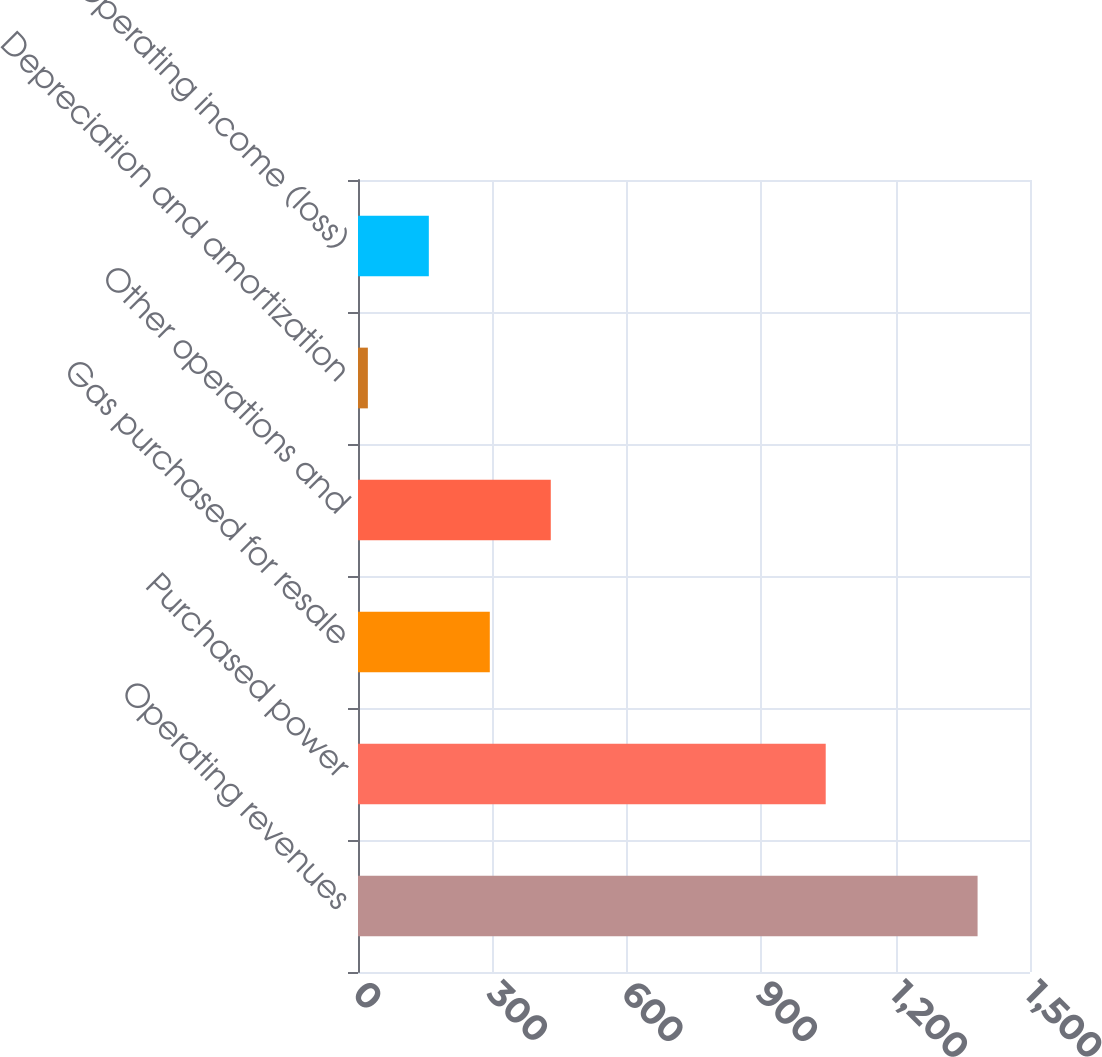Convert chart to OTSL. <chart><loc_0><loc_0><loc_500><loc_500><bar_chart><fcel>Operating revenues<fcel>Purchased power<fcel>Gas purchased for resale<fcel>Other operations and<fcel>Depreciation and amortization<fcel>Operating income (loss)<nl><fcel>1383<fcel>1044<fcel>294.2<fcel>430.3<fcel>22<fcel>158.1<nl></chart> 